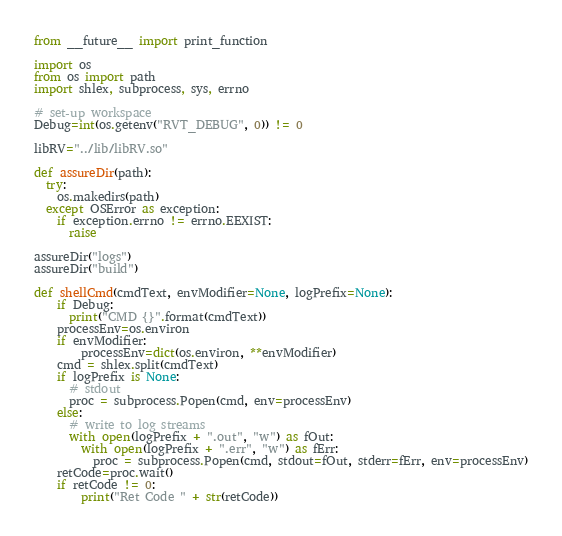<code> <loc_0><loc_0><loc_500><loc_500><_Python_>from __future__ import print_function

import os
from os import path
import shlex, subprocess, sys, errno

# set-up workspace
Debug=int(os.getenv("RVT_DEBUG", 0)) != 0

libRV="../lib/libRV.so"

def assureDir(path):
  try:
    os.makedirs(path)
  except OSError as exception:
    if exception.errno != errno.EEXIST:
      raise

assureDir("logs")
assureDir("build")

def shellCmd(cmdText, envModifier=None, logPrefix=None):
    if Debug:
      print("CMD {}".format(cmdText))
    processEnv=os.environ
    if envModifier:
        processEnv=dict(os.environ, **envModifier)
    cmd = shlex.split(cmdText)
    if logPrefix is None:
      # stdout
      proc = subprocess.Popen(cmd, env=processEnv)
    else:
      # write to log streams
      with open(logPrefix + ".out", "w") as fOut:
        with open(logPrefix + ".err", "w") as fErr:   
          proc = subprocess.Popen(cmd, stdout=fOut, stderr=fErr, env=processEnv)
    retCode=proc.wait()
    if retCode != 0:
        print("Ret Code " + str(retCode))</code> 